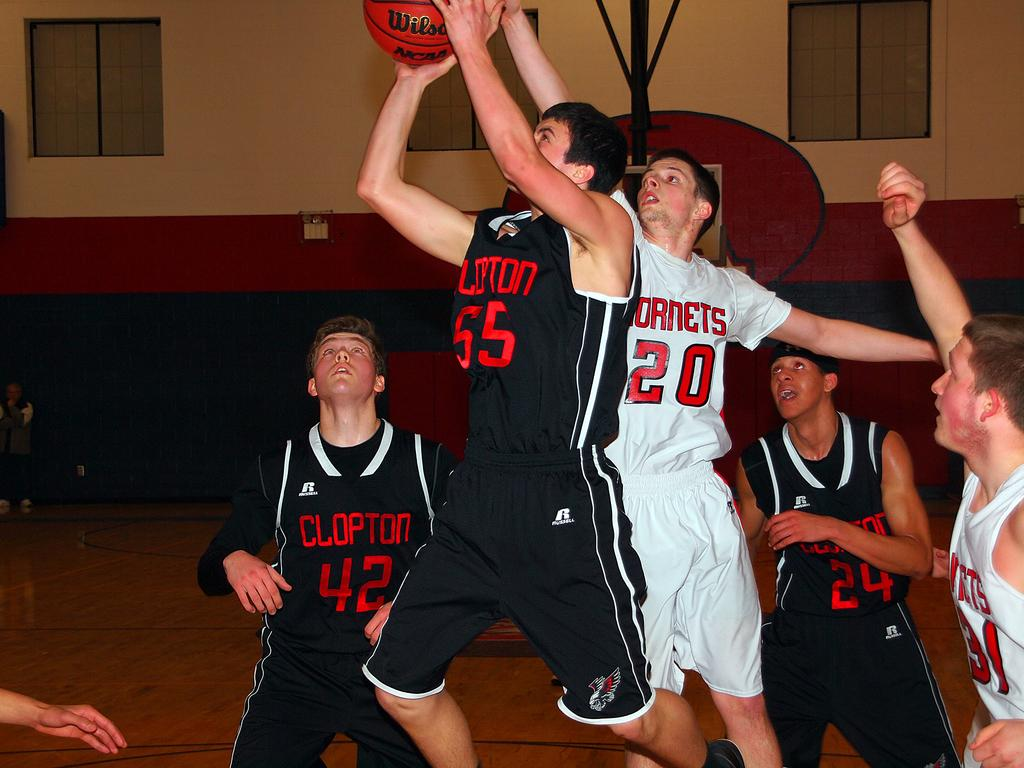Provide a one-sentence caption for the provided image. a few players with one wearing the number 20. 